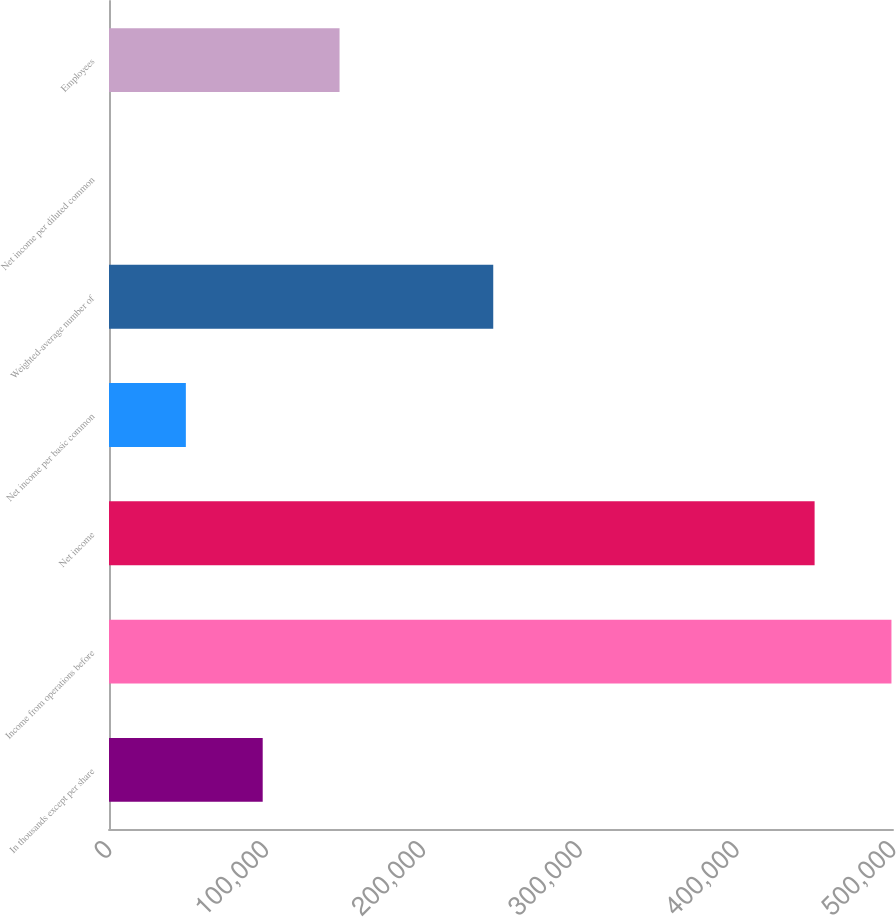<chart> <loc_0><loc_0><loc_500><loc_500><bar_chart><fcel>In thousands except per share<fcel>Income from operations before<fcel>Net income<fcel>Net income per basic common<fcel>Weighted-average number of<fcel>Net income per diluted common<fcel>Employees<nl><fcel>98025.2<fcel>499013<fcel>450003<fcel>49015.2<fcel>245055<fcel>5.2<fcel>147035<nl></chart> 